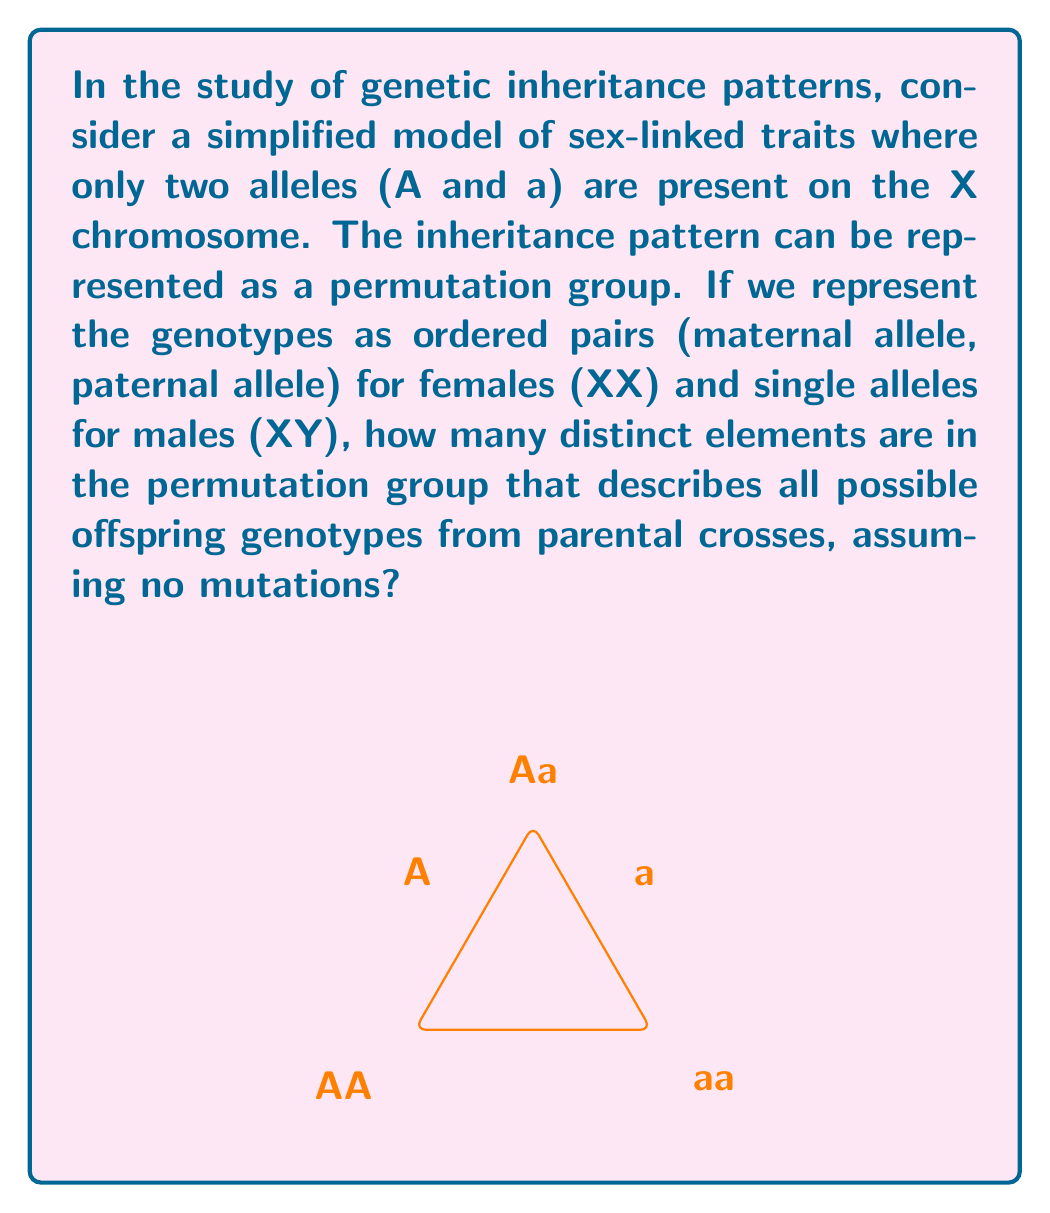Can you solve this math problem? To solve this problem, let's approach it step-by-step:

1) First, let's identify all possible genotypes:
   Females (XX): AA, Aa, aa
   Males (XY): A, a

2) Now, let's consider all possible parental crosses:
   Female × Male: (AA × A), (AA × a), (Aa × A), (Aa × a), (aa × A), (aa × a)

3) For each cross, we need to determine the possible offspring genotypes:

   (AA × A) → AA, A
   (AA × a) → Aa, A
   (Aa × A) → AA, Aa, A, a
   (Aa × a) → Aa, aa, A, a
   (aa × A) → Aa, A
   (aa × a) → aa, a

4) The permutation group will consist of all unique mappings from parental genotypes to offspring genotypes. Each element in the group is a permutation that represents a specific inheritance pattern.

5) To count the number of elements, we need to consider how many ways we can map each parental genotype to its possible offspring genotypes:

   (AA × A): 2 ways (AA→AA, A→A) or (AA→A, A→AA)
   (AA × a): 2 ways (AA→Aa, a→A) or (AA→A, a→Aa)
   (Aa × A): 4! = 24 ways (permutations of AA, Aa, A, a)
   (Aa × a): 4! = 24 ways (permutations of Aa, aa, A, a)
   (aa × A): 2 ways (aa→Aa, A→A) or (aa→A, A→Aa)
   (aa × a): 2 ways (aa→aa, a→a) or (aa→a, a→aa)

6) The total number of elements in the permutation group is the product of these possibilities:

   $2 \times 2 \times 24 \times 24 \times 2 \times 2 = 9,216$

Therefore, the permutation group describing all possible offspring genotypes from parental crosses contains 9,216 distinct elements.
Answer: 9,216 